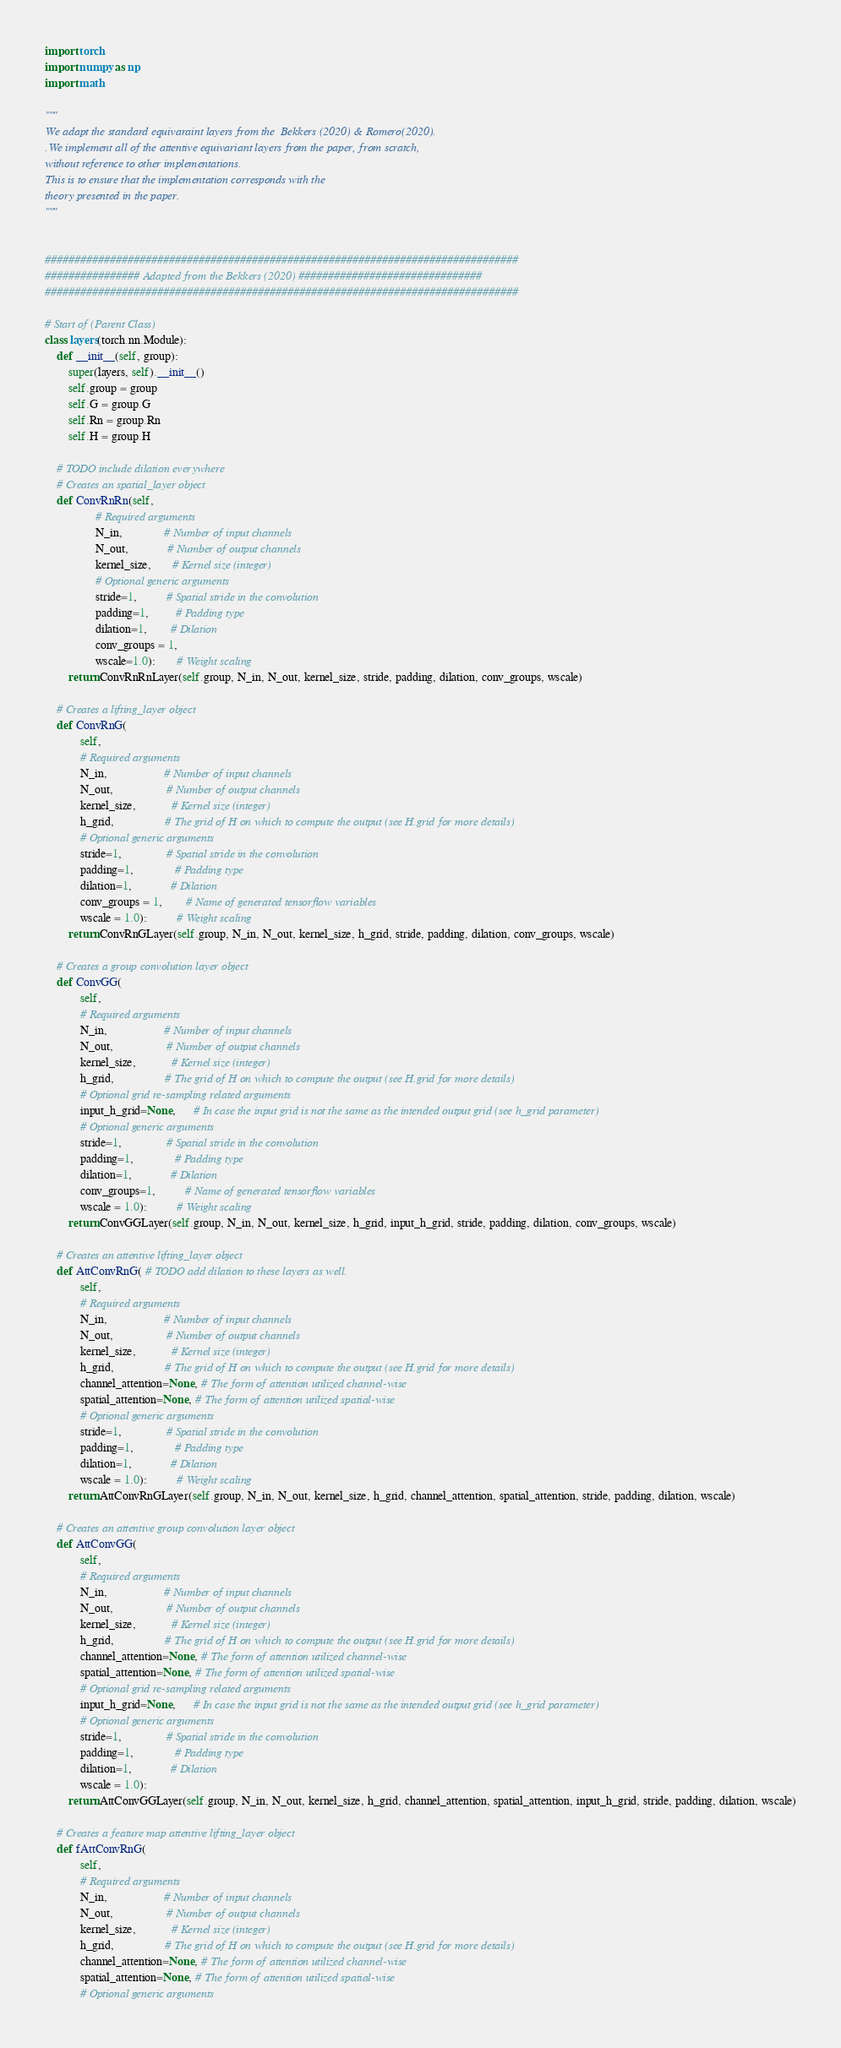<code> <loc_0><loc_0><loc_500><loc_500><_Python_>import torch
import numpy as np
import math

"""
We adapt the standard equivaraint layers from the  Bekkers (2020) & Romero(2020).
.We implement all of the attentive equivariant layers from the paper, from scratch,
without reference to other implementations.
This is to ensure that the implementation corresponds with the
theory presented in the paper.
"""


################################################################################
################ Adapted from the Bekkers (2020) ###############################
################################################################################

# Start of (Parent Class)
class layers(torch.nn.Module):
    def __init__(self, group):
        super(layers, self).__init__()
        self.group = group
        self.G = group.G
        self.Rn = group.Rn
        self.H = group.H

    # TODO include dilation everywhere
    # Creates an spatial_layer object
    def ConvRnRn(self,
                 # Required arguments
                 N_in,              # Number of input channels
                 N_out,             # Number of output channels
                 kernel_size,       # Kernel size (integer)
                 # Optional generic arguments
                 stride=1,          # Spatial stride in the convolution
                 padding=1,         # Padding type
                 dilation=1,        # Dilation
                 conv_groups = 1,
                 wscale=1.0):       # Weight scaling
        return ConvRnRnLayer(self.group, N_in, N_out, kernel_size, stride, padding, dilation, conv_groups, wscale)

    # Creates a lifting_layer object
    def ConvRnG(
            self,
            # Required arguments
            N_in,                   # Number of input channels
            N_out,                  # Number of output channels
            kernel_size,            # Kernel size (integer)
            h_grid,                 # The grid of H on which to compute the output (see H.grid for more details)
            # Optional generic arguments
            stride=1,               # Spatial stride in the convolution
            padding=1,              # Padding type
            dilation=1,             # Dilation
            conv_groups = 1,        # Name of generated tensorflow variables
            wscale = 1.0):          # Weight scaling
        return ConvRnGLayer(self.group, N_in, N_out, kernel_size, h_grid, stride, padding, dilation, conv_groups, wscale)

    # Creates a group convolution layer object
    def ConvGG(
            self,
            # Required arguments
            N_in,                   # Number of input channels
            N_out,                  # Number of output channels
            kernel_size,            # Kernel size (integer)
            h_grid,                 # The grid of H on which to compute the output (see H.grid for more details)
            # Optional grid re-sampling related arguments
            input_h_grid=None,      # In case the input grid is not the same as the intended output grid (see h_grid parameter)
            # Optional generic arguments
            stride=1,               # Spatial stride in the convolution
            padding=1,              # Padding type
            dilation=1,             # Dilation
            conv_groups=1,          # Name of generated tensorflow variables
            wscale = 1.0):          # Weight scaling
        return ConvGGLayer(self.group, N_in, N_out, kernel_size, h_grid, input_h_grid, stride, padding, dilation, conv_groups, wscale)

    # Creates an attentive lifting_layer object
    def AttConvRnG( # TODO add dilation to these layers as well.
            self,
            # Required arguments
            N_in,                   # Number of input channels
            N_out,                  # Number of output channels
            kernel_size,            # Kernel size (integer)
            h_grid,                 # The grid of H on which to compute the output (see H.grid for more details)
            channel_attention=None, # The form of attention utilized channel-wise
            spatial_attention=None, # The form of attention utilized spatial-wise
            # Optional generic arguments
            stride=1,               # Spatial stride in the convolution
            padding=1,              # Padding type
            dilation=1,             # Dilation
            wscale = 1.0):          # Weight scaling
        return AttConvRnGLayer(self.group, N_in, N_out, kernel_size, h_grid, channel_attention, spatial_attention, stride, padding, dilation, wscale)

    # Creates an attentive group convolution layer object
    def AttConvGG(
            self,
            # Required arguments
            N_in,                   # Number of input channels
            N_out,                  # Number of output channels
            kernel_size,            # Kernel size (integer)
            h_grid,                 # The grid of H on which to compute the output (see H.grid for more details)
            channel_attention=None, # The form of attention utilized channel-wise
            spatial_attention=None, # The form of attention utilized spatial-wise
            # Optional grid re-sampling related arguments
            input_h_grid=None,      # In case the input grid is not the same as the intended output grid (see h_grid parameter)
            # Optional generic arguments
            stride=1,               # Spatial stride in the convolution
            padding=1,              # Padding type
            dilation=1,             # Dilation
            wscale = 1.0):
        return AttConvGGLayer(self.group, N_in, N_out, kernel_size, h_grid, channel_attention, spatial_attention, input_h_grid, stride, padding, dilation, wscale)

    # Creates a feature map attentive lifting_layer object
    def fAttConvRnG(
            self,
            # Required arguments
            N_in,                   # Number of input channels
            N_out,                  # Number of output channels
            kernel_size,            # Kernel size (integer)
            h_grid,                 # The grid of H on which to compute the output (see H.grid for more details)
            channel_attention=None, # The form of attention utilized channel-wise
            spatial_attention=None, # The form of attention utilized spatial-wise
            # Optional generic arguments</code> 